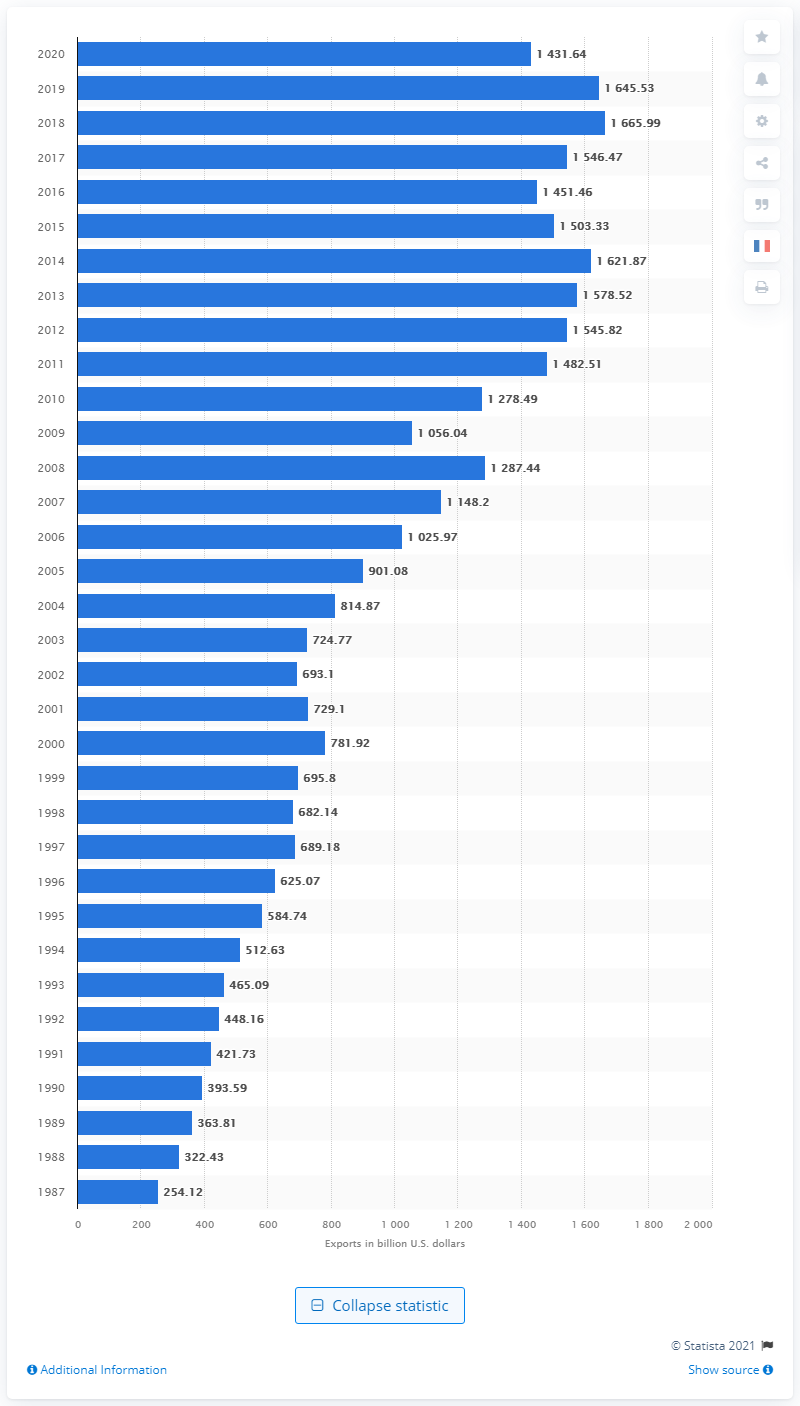Specify some key components in this picture. In 2020, the value of U.S. exports to the world was 1,431.64 billion dollars. 